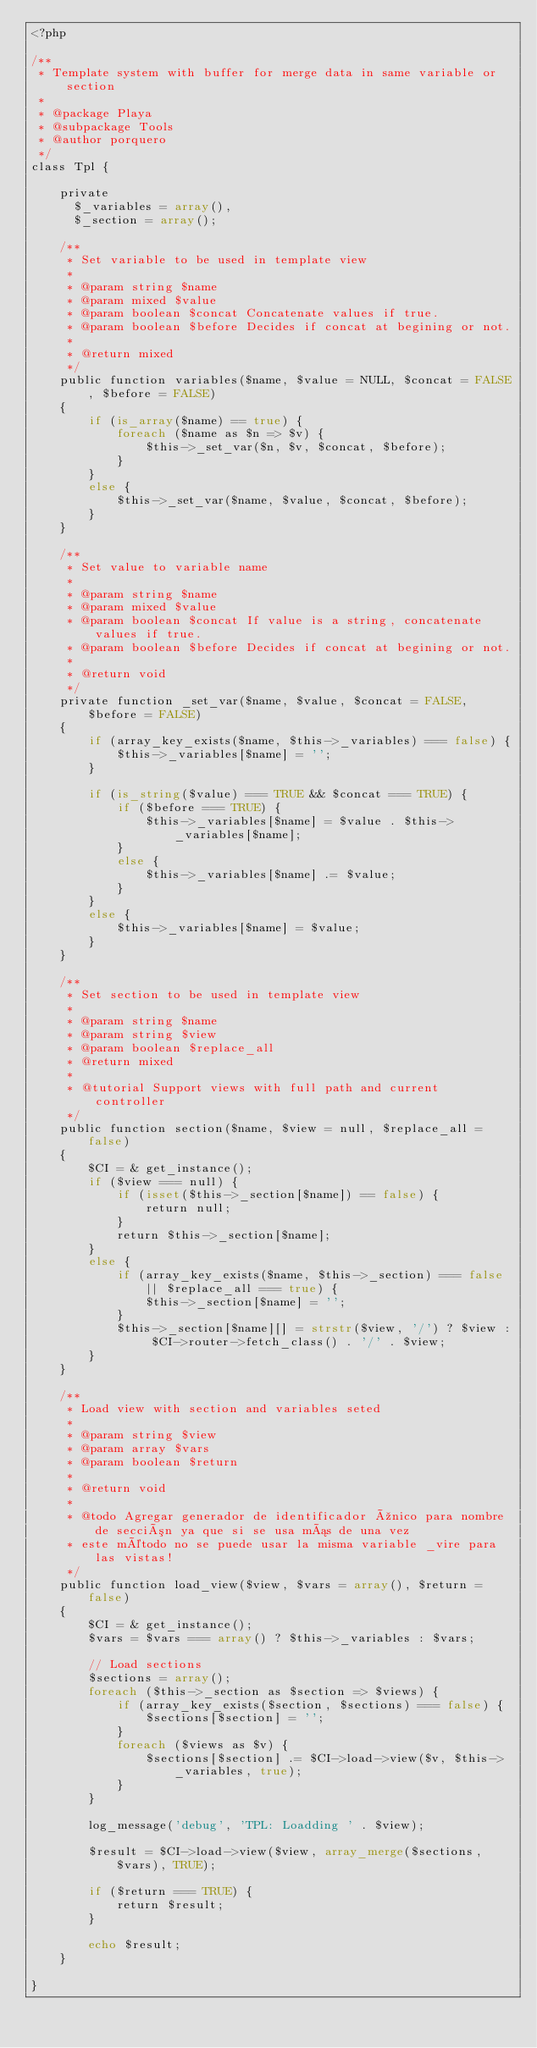Convert code to text. <code><loc_0><loc_0><loc_500><loc_500><_PHP_><?php

/**
 * Template system with buffer for merge data in same variable or section
 *
 * @package Playa
 * @subpackage Tools
 * @author porquero
 */
class Tpl {

    private
      $_variables = array(),
      $_section = array();

    /**
     * Set variable to be used in template view
     *
     * @param string $name
     * @param mixed $value
     * @param boolean $concat Concatenate values if true.
     * @param boolean $before Decides if concat at begining or not.
     *
     * @return mixed
     */
    public function variables($name, $value = NULL, $concat = FALSE, $before = FALSE)
    {
        if (is_array($name) == true) {
            foreach ($name as $n => $v) {
                $this->_set_var($n, $v, $concat, $before);
            }
        }
        else {
            $this->_set_var($name, $value, $concat, $before);
        }
    }

    /**
     * Set value to variable name
     *
     * @param string $name
     * @param mixed $value
     * @param boolean $concat If value is a string, concatenate values if true.
     * @param boolean $before Decides if concat at begining or not.
     *
     * @return void
     */
    private function _set_var($name, $value, $concat = FALSE, $before = FALSE)
    {
        if (array_key_exists($name, $this->_variables) === false) {
            $this->_variables[$name] = '';
        }

        if (is_string($value) === TRUE && $concat === TRUE) {
            if ($before === TRUE) {
                $this->_variables[$name] = $value . $this->_variables[$name];
            }
            else {
                $this->_variables[$name] .= $value;
            }
        }
        else {
            $this->_variables[$name] = $value;
        }
    }

    /**
     * Set section to be used in template view
     *
     * @param string $name
     * @param string $view
     * @param boolean $replace_all
     * @return mixed
     *
     * @tutorial Support views with full path and current controller
     */
    public function section($name, $view = null, $replace_all = false)
    {
        $CI = & get_instance();
        if ($view === null) {
            if (isset($this->_section[$name]) == false) {
                return null;
            }
            return $this->_section[$name];
        }
        else {
            if (array_key_exists($name, $this->_section) === false || $replace_all === true) {
                $this->_section[$name] = '';
            }
            $this->_section[$name][] = strstr($view, '/') ? $view : $CI->router->fetch_class() . '/' . $view;
        }
    }

    /**
     * Load view with section and variables seted
     *
     * @param string $view
     * @param array $vars
     * @param boolean $return
     *
     * @return void
     *
     * @todo Agregar generador de identificador único para nombre de sección ya que si se usa más de una vez
     * este método no se puede usar la misma variable _vire para las vistas!
     */
    public function load_view($view, $vars = array(), $return = false)
    {
        $CI = & get_instance();
        $vars = $vars === array() ? $this->_variables : $vars;

        // Load sections
        $sections = array();
        foreach ($this->_section as $section => $views) {
            if (array_key_exists($section, $sections) === false) {
                $sections[$section] = '';
            }
            foreach ($views as $v) {
                $sections[$section] .= $CI->load->view($v, $this->_variables, true);
            }
        }

        log_message('debug', 'TPL: Loadding ' . $view);
        
        $result = $CI->load->view($view, array_merge($sections, $vars), TRUE);

        if ($return === TRUE) {
            return $result;
        }

        echo $result;
    }

}
</code> 